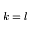Convert formula to latex. <formula><loc_0><loc_0><loc_500><loc_500>k = l</formula> 